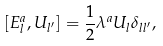<formula> <loc_0><loc_0><loc_500><loc_500>[ E _ { l } ^ { a } , U _ { l ^ { \prime } } ] = \frac { 1 } { 2 } \lambda ^ { a } U _ { l } \delta _ { l l ^ { \prime } } ,</formula> 